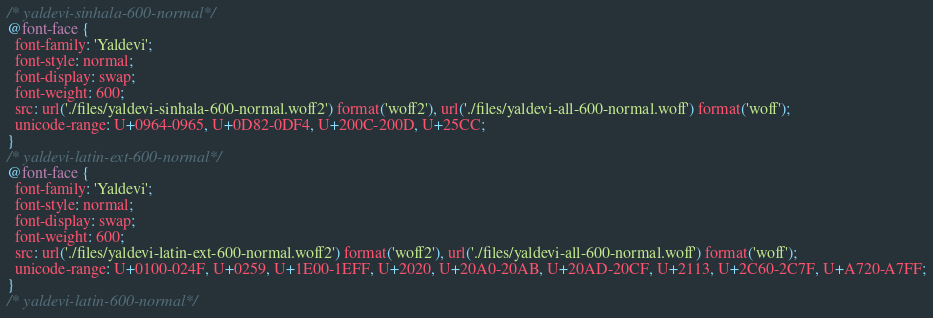Convert code to text. <code><loc_0><loc_0><loc_500><loc_500><_CSS_>/* yaldevi-sinhala-600-normal*/
@font-face {
  font-family: 'Yaldevi';
  font-style: normal;
  font-display: swap;
  font-weight: 600;
  src: url('./files/yaldevi-sinhala-600-normal.woff2') format('woff2'), url('./files/yaldevi-all-600-normal.woff') format('woff');
  unicode-range: U+0964-0965, U+0D82-0DF4, U+200C-200D, U+25CC;
}
/* yaldevi-latin-ext-600-normal*/
@font-face {
  font-family: 'Yaldevi';
  font-style: normal;
  font-display: swap;
  font-weight: 600;
  src: url('./files/yaldevi-latin-ext-600-normal.woff2') format('woff2'), url('./files/yaldevi-all-600-normal.woff') format('woff');
  unicode-range: U+0100-024F, U+0259, U+1E00-1EFF, U+2020, U+20A0-20AB, U+20AD-20CF, U+2113, U+2C60-2C7F, U+A720-A7FF;
}
/* yaldevi-latin-600-normal*/</code> 